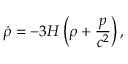<formula> <loc_0><loc_0><loc_500><loc_500>{ \dot { \rho } } = - 3 H \left ( \rho + { \frac { p } { c ^ { 2 } } } \right ) ,</formula> 